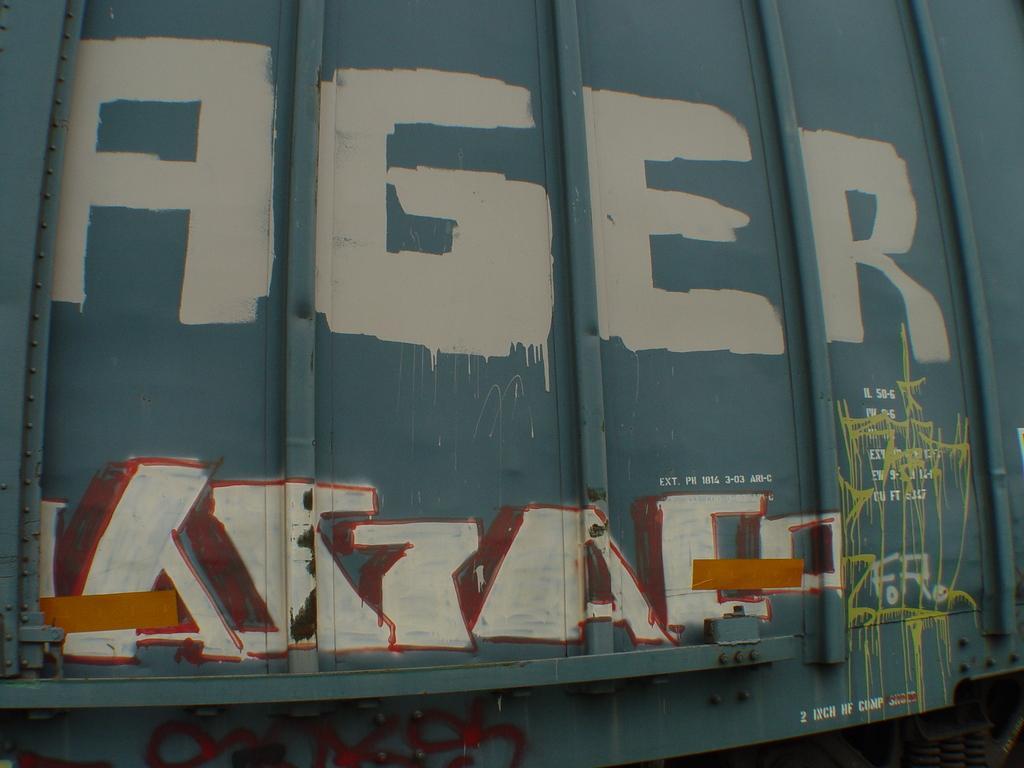Could you give a brief overview of what you see in this image? Graffiti is on vehicle. 